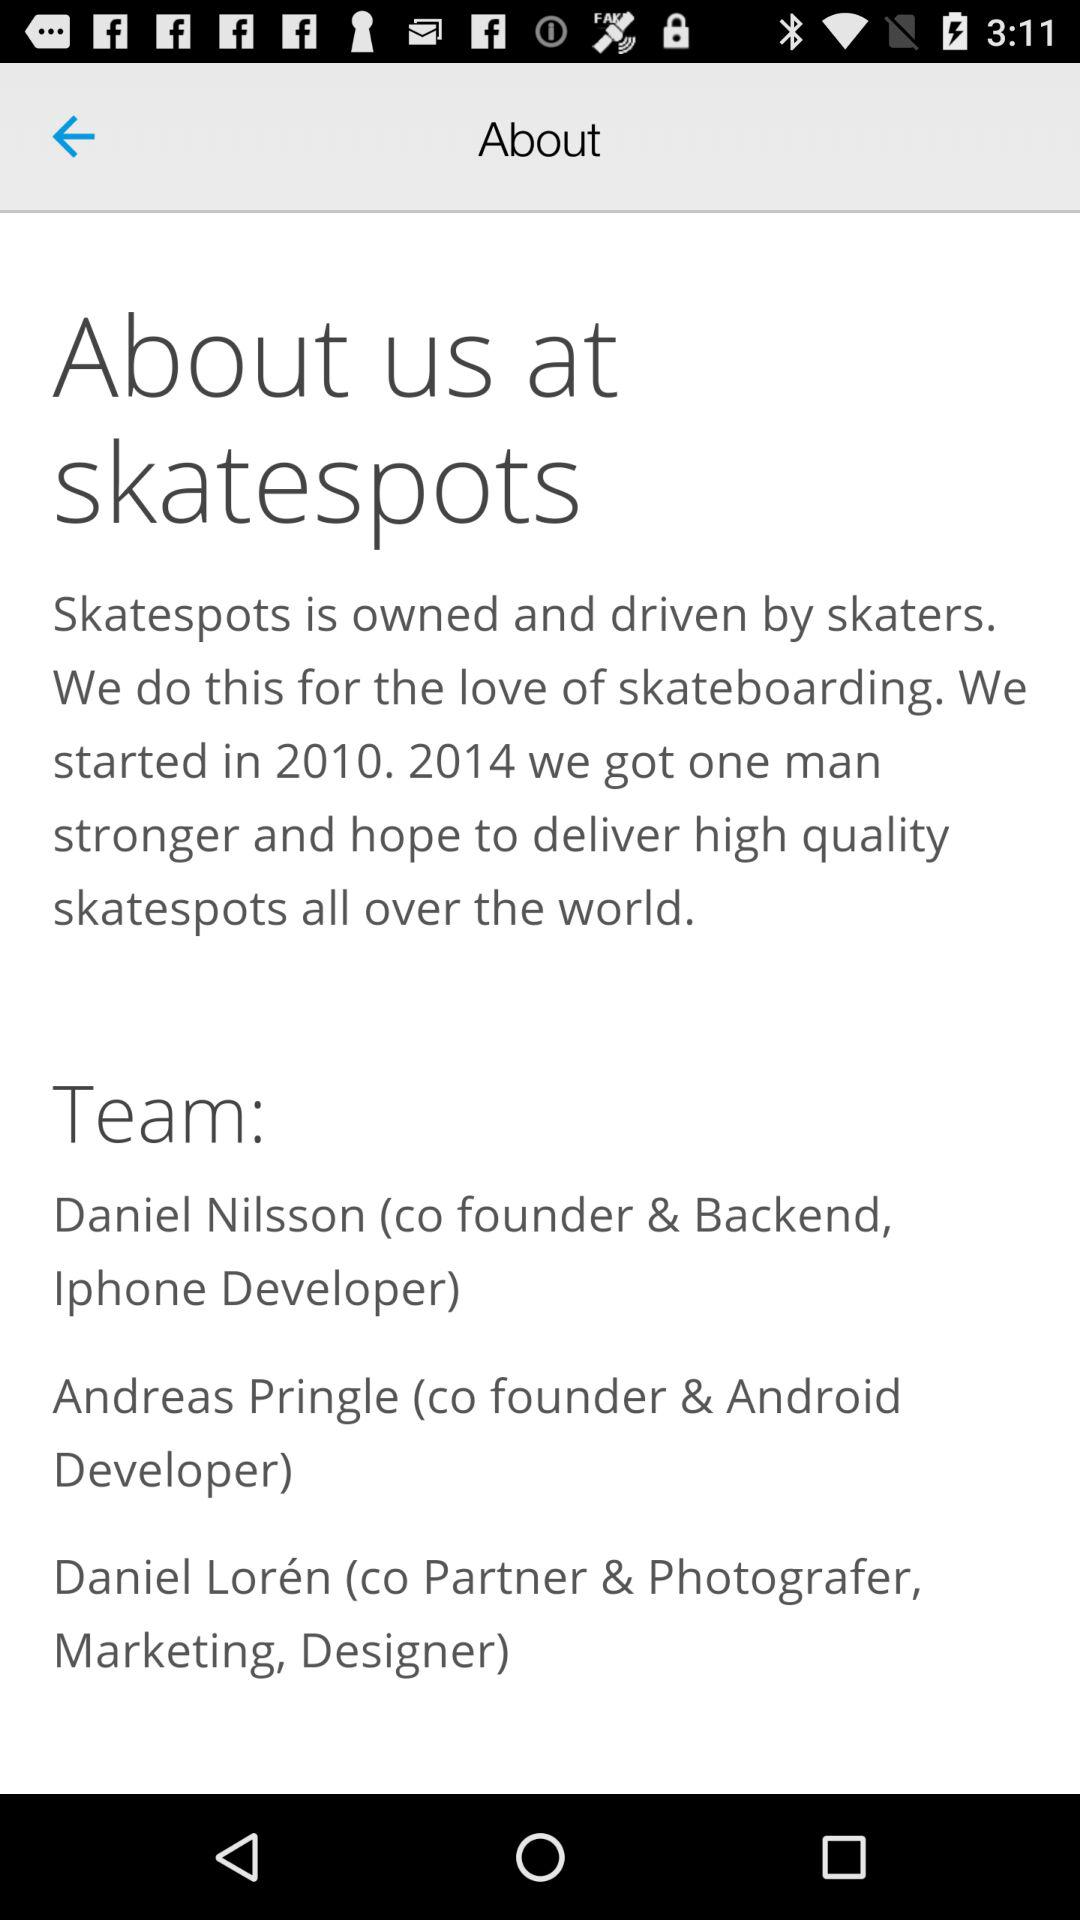What's the team players name? The team players names are: Daniel Nilsson, Andreas Pringle, and Daniel Lorén. 